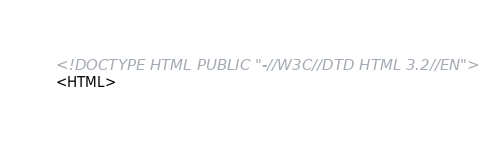<code> <loc_0><loc_0><loc_500><loc_500><_HTML_><!DOCTYPE HTML PUBLIC "-//W3C//DTD HTML 3.2//EN">
<HTML></code> 